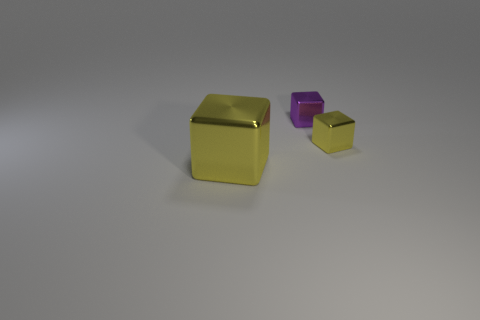What material is the tiny cube that is the same color as the large object?
Provide a succinct answer. Metal. How many tiny blocks are the same color as the big metallic object?
Your answer should be very brief. 1. Is the material of the large yellow thing the same as the thing that is behind the small yellow shiny thing?
Keep it short and to the point. Yes. There is a metallic cube that is in front of the purple cube and left of the tiny yellow object; what is its color?
Provide a succinct answer. Yellow. What shape is the tiny shiny object on the right side of the purple block?
Your answer should be compact. Cube. What is the size of the metal thing that is on the left side of the object behind the yellow metallic block that is behind the large yellow shiny thing?
Your response must be concise. Large. There is a yellow thing behind the big metallic thing; how many large yellow shiny things are in front of it?
Ensure brevity in your answer.  1. How big is the object that is both to the left of the tiny yellow metal object and right of the large cube?
Provide a short and direct response. Small. What number of rubber objects are either big red objects or large yellow cubes?
Provide a succinct answer. 0. What is the purple block made of?
Make the answer very short. Metal. 